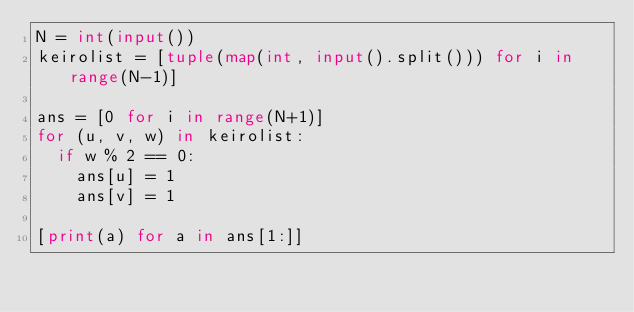<code> <loc_0><loc_0><loc_500><loc_500><_Python_>N = int(input())
keirolist = [tuple(map(int, input().split())) for i in range(N-1)]

ans = [0 for i in range(N+1)]
for (u, v, w) in keirolist:
  if w % 2 == 0:
    ans[u] = 1
    ans[v] = 1

[print(a) for a in ans[1:]]</code> 